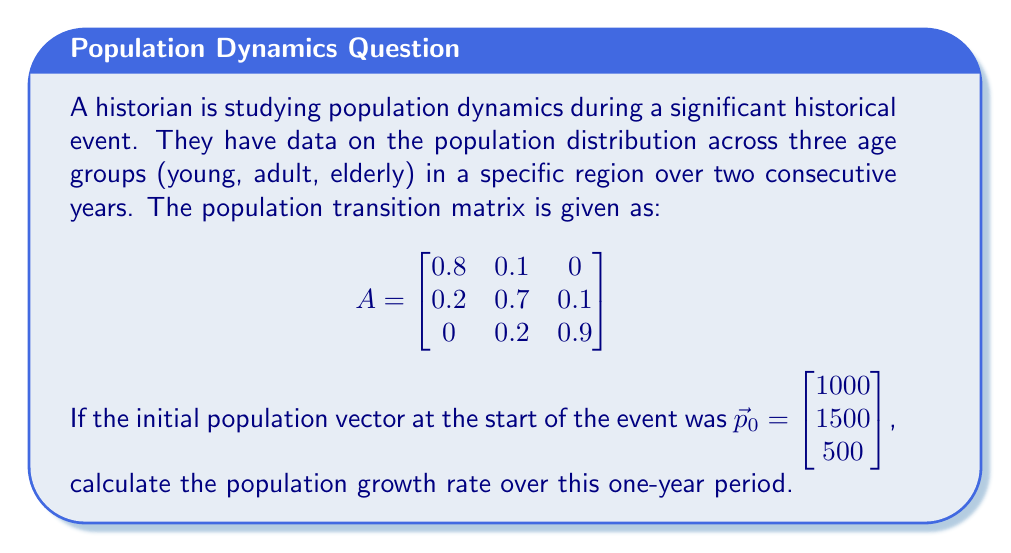Can you solve this math problem? To solve this problem, we'll follow these steps:

1) First, we need to calculate the population vector after one year. We do this by multiplying the transition matrix $A$ with the initial population vector $\vec{p}_0$:

   $$\vec{p}_1 = A\vec{p}_0 = \begin{bmatrix}
   0.8 & 0.1 & 0 \\
   0.2 & 0.7 & 0.1 \\
   0 & 0.2 & 0.9
   \end{bmatrix} \begin{bmatrix} 1000 \\ 1500 \\ 500 \end{bmatrix}$$

2) Performing the matrix multiplication:

   $$\vec{p}_1 = \begin{bmatrix}
   0.8(1000) + 0.1(1500) + 0(500) \\
   0.2(1000) + 0.7(1500) + 0.1(500) \\
   0(1000) + 0.2(1500) + 0.9(500)
   \end{bmatrix} = \begin{bmatrix} 950 \\ 1300 \\ 750 \end{bmatrix}$$

3) Now we have the population vector after one year. To calculate the growth rate, we need to find the total population at the start and end of the year:

   Initial total population: $1000 + 1500 + 500 = 3000$
   Final total population: $950 + 1300 + 750 = 3000$

4) The population growth rate is calculated using the formula:

   $$\text{Growth Rate} = \frac{\text{Final Population} - \text{Initial Population}}{\text{Initial Population}} \times 100\%$$

5) Plugging in our values:

   $$\text{Growth Rate} = \frac{3000 - 3000}{3000} \times 100\% = 0\%$$
Answer: The population growth rate over the one-year period is 0%. 